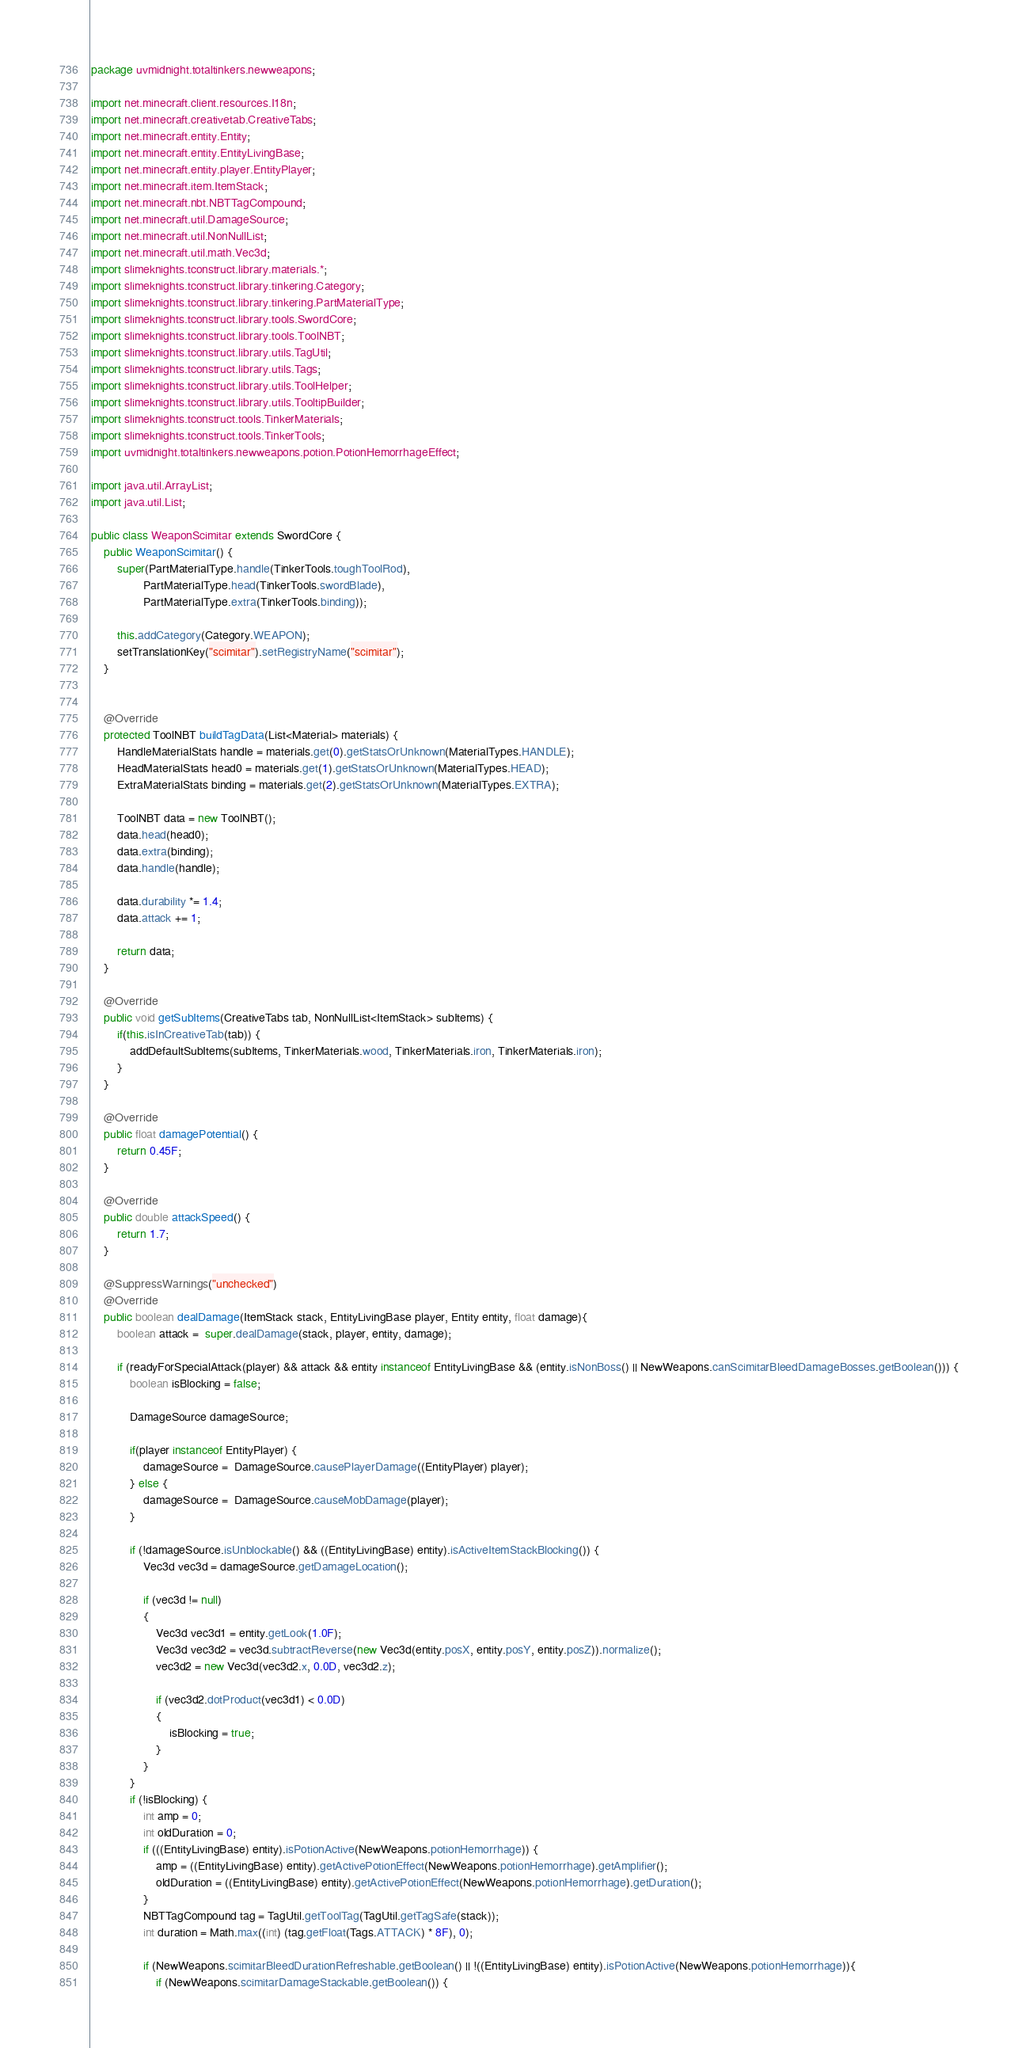<code> <loc_0><loc_0><loc_500><loc_500><_Java_>package uvmidnight.totaltinkers.newweapons;

import net.minecraft.client.resources.I18n;
import net.minecraft.creativetab.CreativeTabs;
import net.minecraft.entity.Entity;
import net.minecraft.entity.EntityLivingBase;
import net.minecraft.entity.player.EntityPlayer;
import net.minecraft.item.ItemStack;
import net.minecraft.nbt.NBTTagCompound;
import net.minecraft.util.DamageSource;
import net.minecraft.util.NonNullList;
import net.minecraft.util.math.Vec3d;
import slimeknights.tconstruct.library.materials.*;
import slimeknights.tconstruct.library.tinkering.Category;
import slimeknights.tconstruct.library.tinkering.PartMaterialType;
import slimeknights.tconstruct.library.tools.SwordCore;
import slimeknights.tconstruct.library.tools.ToolNBT;
import slimeknights.tconstruct.library.utils.TagUtil;
import slimeknights.tconstruct.library.utils.Tags;
import slimeknights.tconstruct.library.utils.ToolHelper;
import slimeknights.tconstruct.library.utils.TooltipBuilder;
import slimeknights.tconstruct.tools.TinkerMaterials;
import slimeknights.tconstruct.tools.TinkerTools;
import uvmidnight.totaltinkers.newweapons.potion.PotionHemorrhageEffect;

import java.util.ArrayList;
import java.util.List;

public class WeaponScimitar extends SwordCore {
    public WeaponScimitar() {
        super(PartMaterialType.handle(TinkerTools.toughToolRod),
                PartMaterialType.head(TinkerTools.swordBlade),
                PartMaterialType.extra(TinkerTools.binding));

        this.addCategory(Category.WEAPON);
        setTranslationKey("scimitar").setRegistryName("scimitar");
    }


    @Override
    protected ToolNBT buildTagData(List<Material> materials) {
        HandleMaterialStats handle = materials.get(0).getStatsOrUnknown(MaterialTypes.HANDLE);
        HeadMaterialStats head0 = materials.get(1).getStatsOrUnknown(MaterialTypes.HEAD);
        ExtraMaterialStats binding = materials.get(2).getStatsOrUnknown(MaterialTypes.EXTRA);

        ToolNBT data = new ToolNBT();
        data.head(head0);
        data.extra(binding);
        data.handle(handle);

        data.durability *= 1.4;
        data.attack += 1;

        return data;
    }

    @Override
    public void getSubItems(CreativeTabs tab, NonNullList<ItemStack> subItems) {
        if(this.isInCreativeTab(tab)) {
            addDefaultSubItems(subItems, TinkerMaterials.wood, TinkerMaterials.iron, TinkerMaterials.iron);
        }
    }

    @Override
    public float damagePotential() {
        return 0.45F;
    }

    @Override
    public double attackSpeed() {
        return 1.7;
    }

    @SuppressWarnings("unchecked")
    @Override
    public boolean dealDamage(ItemStack stack, EntityLivingBase player, Entity entity, float damage){
        boolean attack =  super.dealDamage(stack, player, entity, damage);

        if (readyForSpecialAttack(player) && attack && entity instanceof EntityLivingBase && (entity.isNonBoss() || NewWeapons.canScimitarBleedDamageBosses.getBoolean())) {
            boolean isBlocking = false;

            DamageSource damageSource;

            if(player instanceof EntityPlayer) {
                damageSource =  DamageSource.causePlayerDamage((EntityPlayer) player);
            } else {
                damageSource =  DamageSource.causeMobDamage(player);
            }

            if (!damageSource.isUnblockable() && ((EntityLivingBase) entity).isActiveItemStackBlocking()) {
                Vec3d vec3d = damageSource.getDamageLocation();

                if (vec3d != null)
                {
                    Vec3d vec3d1 = entity.getLook(1.0F);
                    Vec3d vec3d2 = vec3d.subtractReverse(new Vec3d(entity.posX, entity.posY, entity.posZ)).normalize();
                    vec3d2 = new Vec3d(vec3d2.x, 0.0D, vec3d2.z);

                    if (vec3d2.dotProduct(vec3d1) < 0.0D)
                    {
                        isBlocking = true;
                    }
                }
            }
            if (!isBlocking) {
                int amp = 0;
                int oldDuration = 0;
                if (((EntityLivingBase) entity).isPotionActive(NewWeapons.potionHemorrhage)) {
                    amp = ((EntityLivingBase) entity).getActivePotionEffect(NewWeapons.potionHemorrhage).getAmplifier();
                    oldDuration = ((EntityLivingBase) entity).getActivePotionEffect(NewWeapons.potionHemorrhage).getDuration();
                }
                NBTTagCompound tag = TagUtil.getToolTag(TagUtil.getTagSafe(stack));
                int duration = Math.max((int) (tag.getFloat(Tags.ATTACK) * 8F), 0);

                if (NewWeapons.scimitarBleedDurationRefreshable.getBoolean() || !((EntityLivingBase) entity).isPotionActive(NewWeapons.potionHemorrhage)){
                    if (NewWeapons.scimitarDamageStackable.getBoolean()) {</code> 